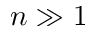Convert formula to latex. <formula><loc_0><loc_0><loc_500><loc_500>n \gg 1</formula> 